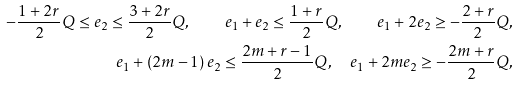<formula> <loc_0><loc_0><loc_500><loc_500>- \frac { 1 + 2 r } { 2 } Q \leq e _ { 2 } \leq \frac { 3 + 2 r } { 2 } Q , \quad e _ { 1 } + e _ { 2 } \leq \frac { 1 + r } { 2 } Q , \quad e _ { 1 } + 2 e _ { 2 } \geq - \frac { 2 + r } { 2 } Q , \\ e _ { 1 } + \left ( 2 m - 1 \right ) e _ { 2 } \leq \frac { 2 m + r - 1 } { 2 } Q , \quad e _ { 1 } + 2 m e _ { 2 } \geq - \frac { 2 m + r } { 2 } Q ,</formula> 